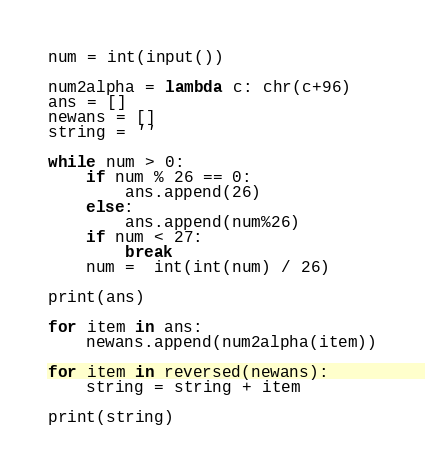<code> <loc_0><loc_0><loc_500><loc_500><_Python_>num = int(input())

num2alpha = lambda c: chr(c+96)
ans = []
newans = []
string = ''

while num > 0:
    if num % 26 == 0:
        ans.append(26)
    else:
        ans.append(num%26)
    if num < 27:
        break
    num =  int(int(num) / 26)
    
print(ans)

for item in ans:
    newans.append(num2alpha(item))

for item in reversed(newans):
    string = string + item

print(string)



</code> 